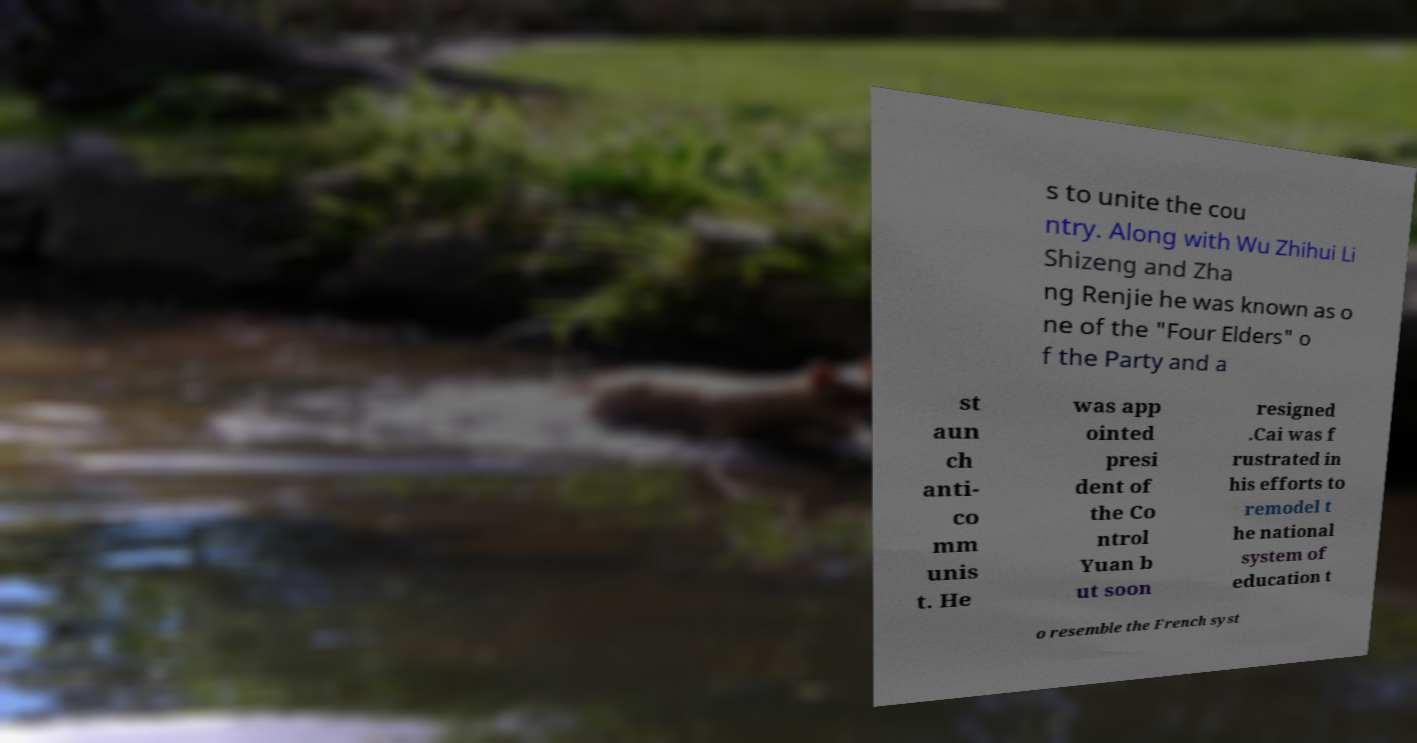For documentation purposes, I need the text within this image transcribed. Could you provide that? s to unite the cou ntry. Along with Wu Zhihui Li Shizeng and Zha ng Renjie he was known as o ne of the "Four Elders" o f the Party and a st aun ch anti- co mm unis t. He was app ointed presi dent of the Co ntrol Yuan b ut soon resigned .Cai was f rustrated in his efforts to remodel t he national system of education t o resemble the French syst 